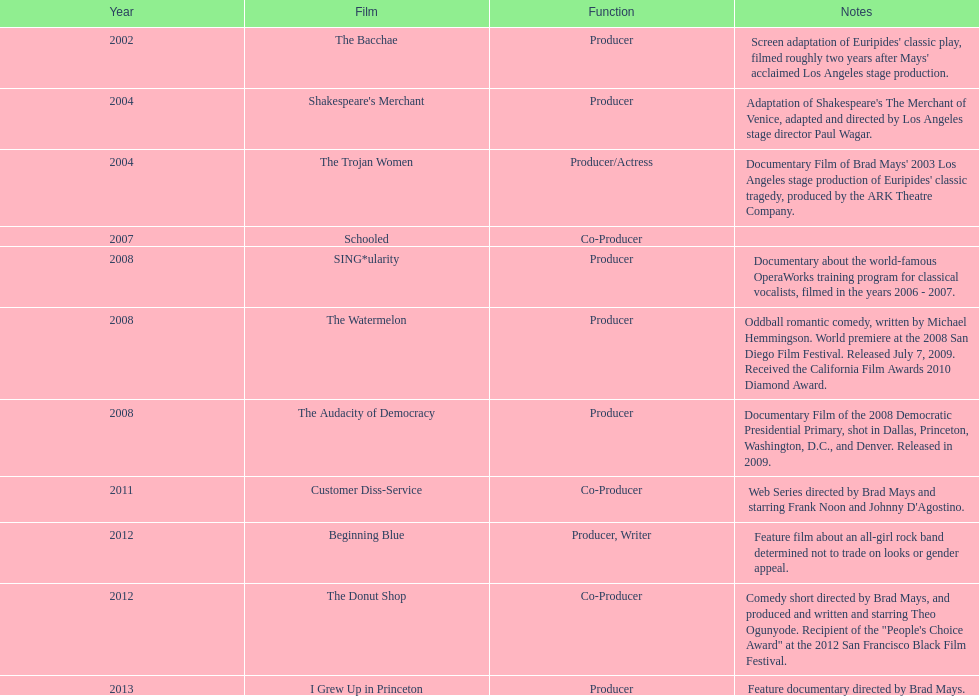In which year did ms. starfelt produce the most films? 2008. 